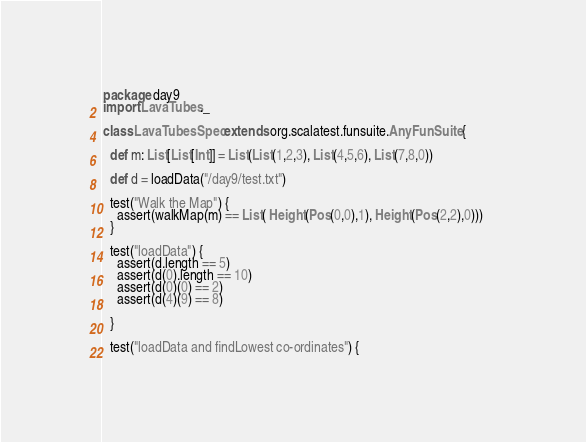<code> <loc_0><loc_0><loc_500><loc_500><_Scala_>package day9
import LavaTubes._

class LavaTubesSpec extends org.scalatest.funsuite.AnyFunSuite {

  def m: List[List[Int]] = List(List(1,2,3), List(4,5,6), List(7,8,0))

  def d = loadData("/day9/test.txt")

  test("Walk the Map") {
    assert(walkMap(m) == List( Height(Pos(0,0),1), Height(Pos(2,2),0)))    
  }

  test("loadData") {
    assert(d.length == 5)
    assert(d(0).length == 10)
    assert(d(0)(0) == 2)
    assert(d(4)(9) == 8)

  }

  test("loadData and findLowest co-ordinates") {</code> 